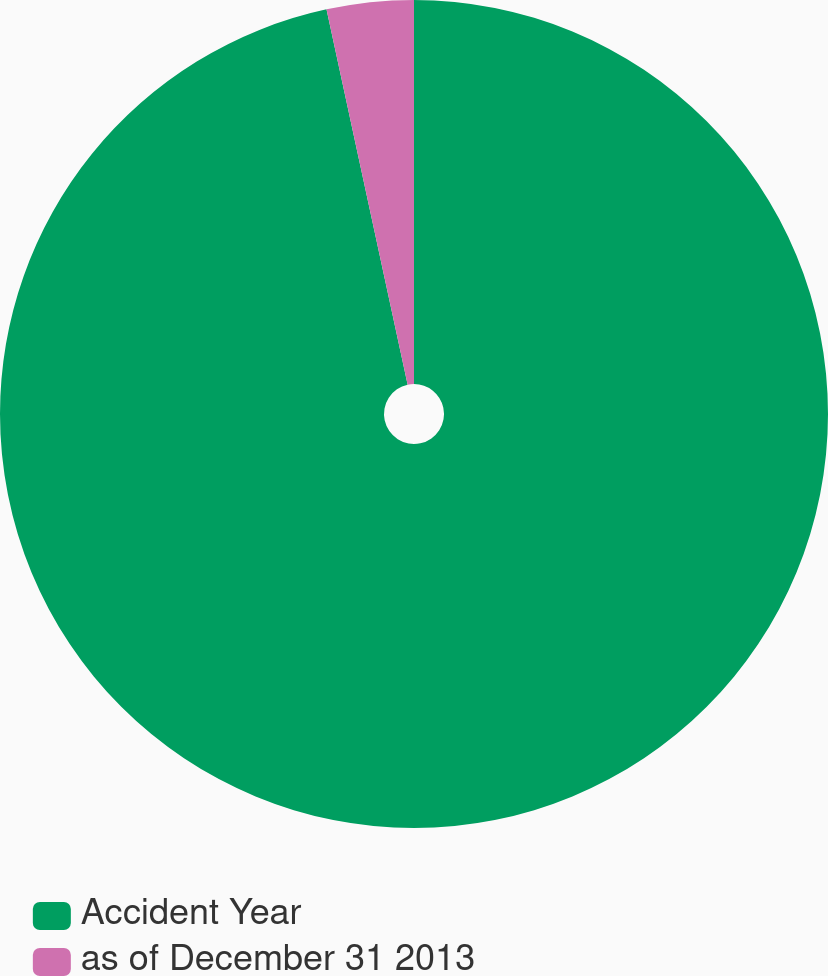Convert chart to OTSL. <chart><loc_0><loc_0><loc_500><loc_500><pie_chart><fcel>Accident Year<fcel>as of December 31 2013<nl><fcel>96.61%<fcel>3.39%<nl></chart> 